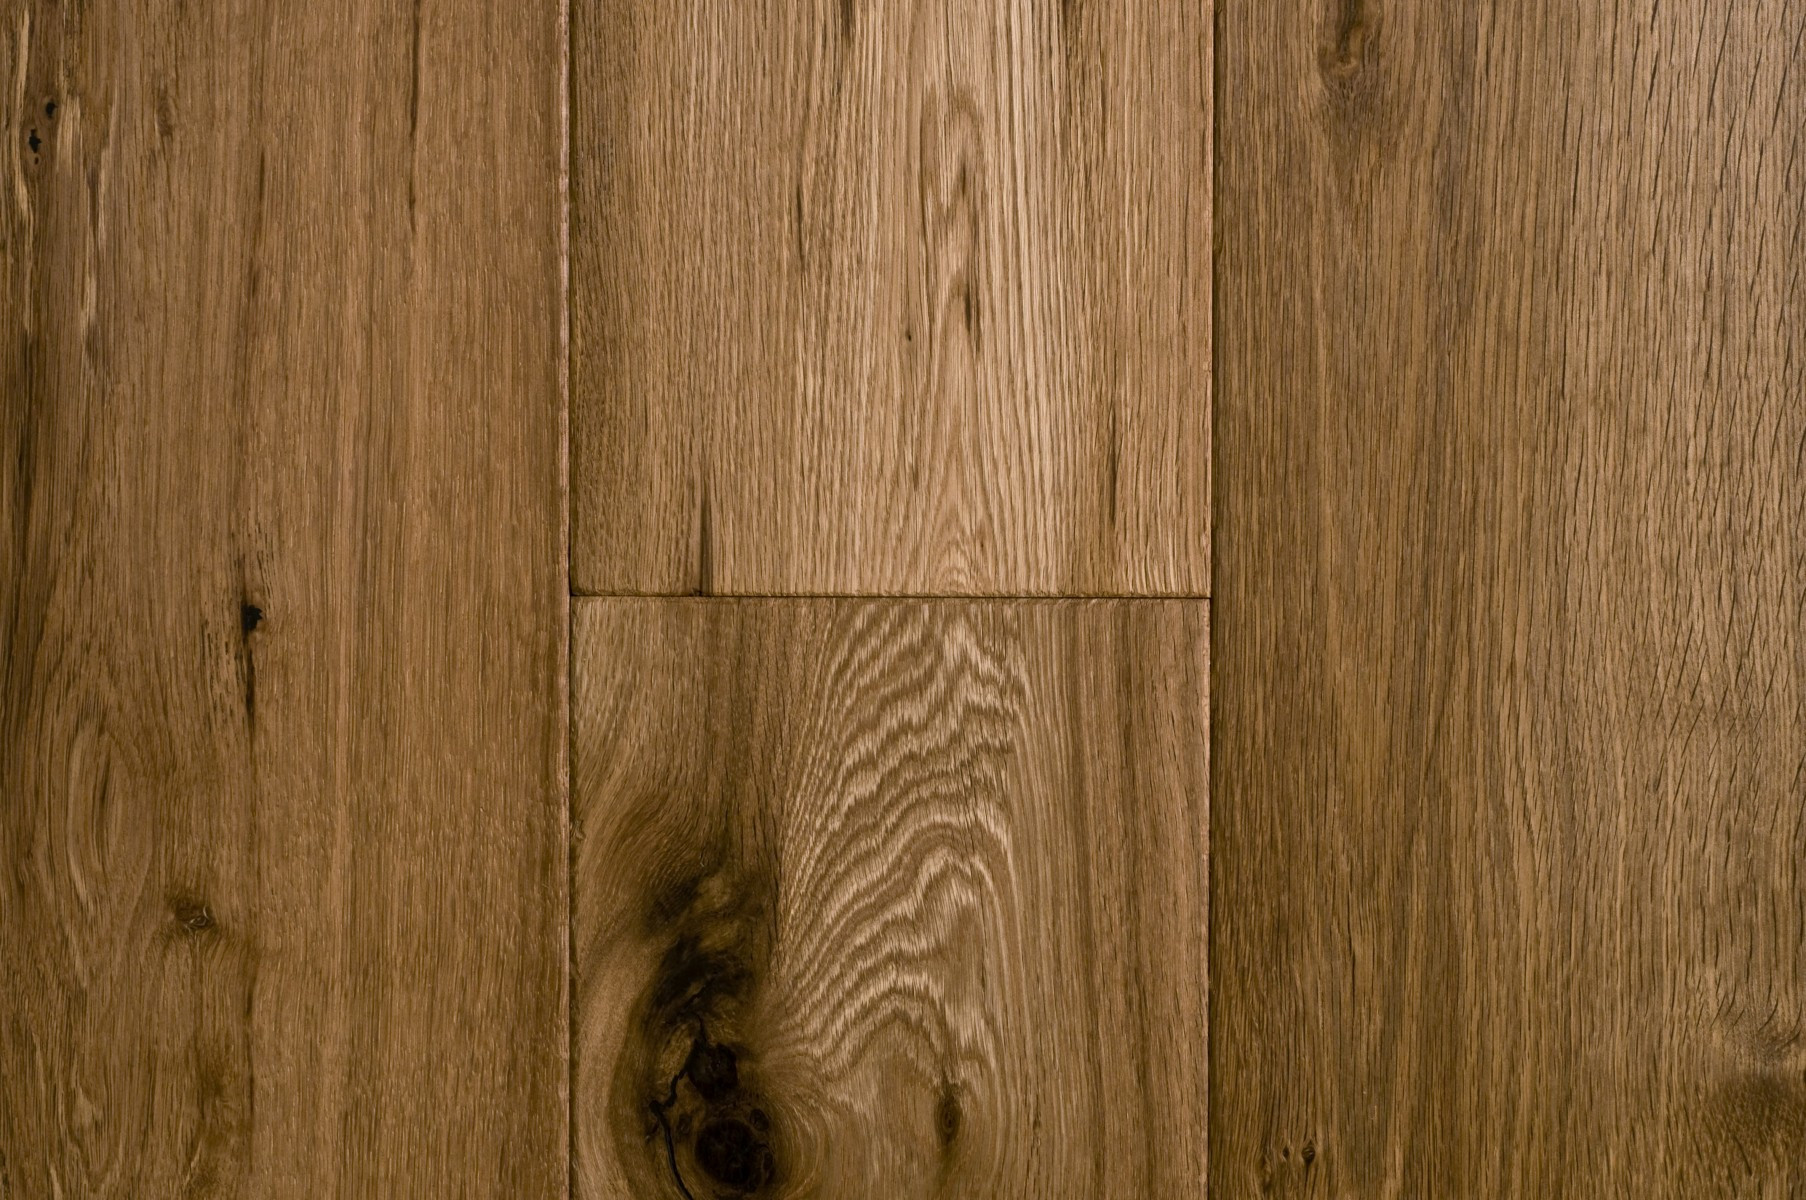What is the likely species of wood used for this flooring based on the grain pattern and color? The wood in the image likely belongs to the oak family, evidenced by its distinctive, straight grain pattern and warm brown color, typical of oak varieties such as white or red oak. These species are favored for flooring due to their durability and aesthetic appeal. Oak wood usually features some unique irregularities, including knots and streaks, aligning well with the wood seen in the image. To confirm the type of oak or to potentially identify other similar looking species, a closer examination with a magnifying glass or consulting with a wood expert would provide more definitive information. 